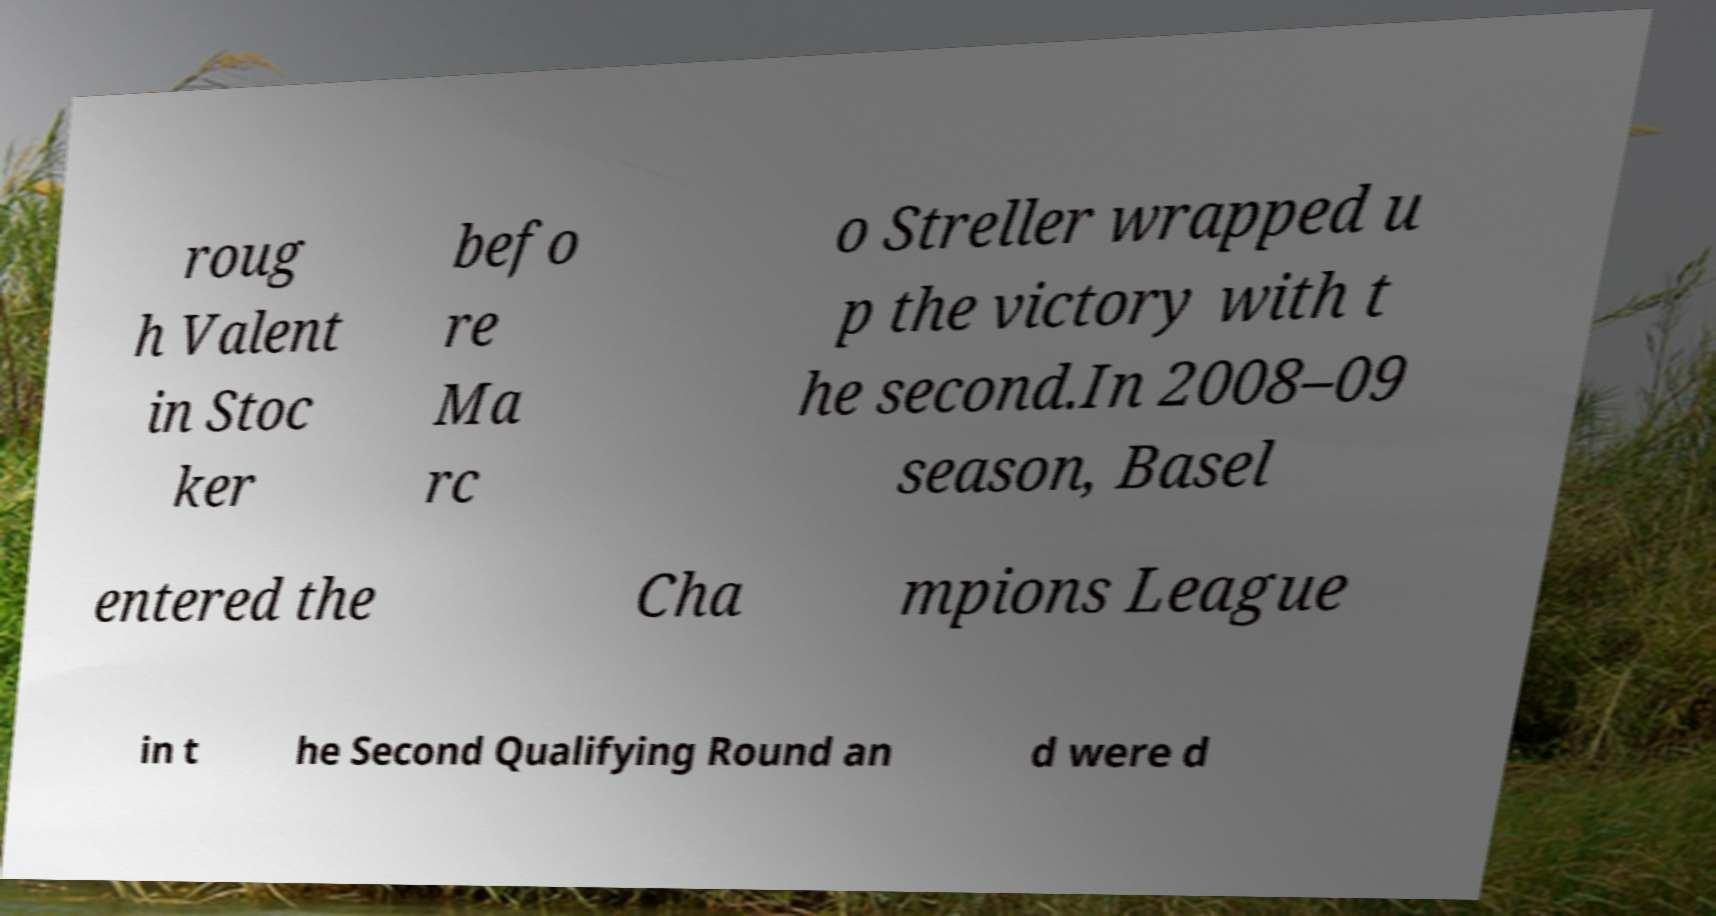There's text embedded in this image that I need extracted. Can you transcribe it verbatim? roug h Valent in Stoc ker befo re Ma rc o Streller wrapped u p the victory with t he second.In 2008–09 season, Basel entered the Cha mpions League in t he Second Qualifying Round an d were d 